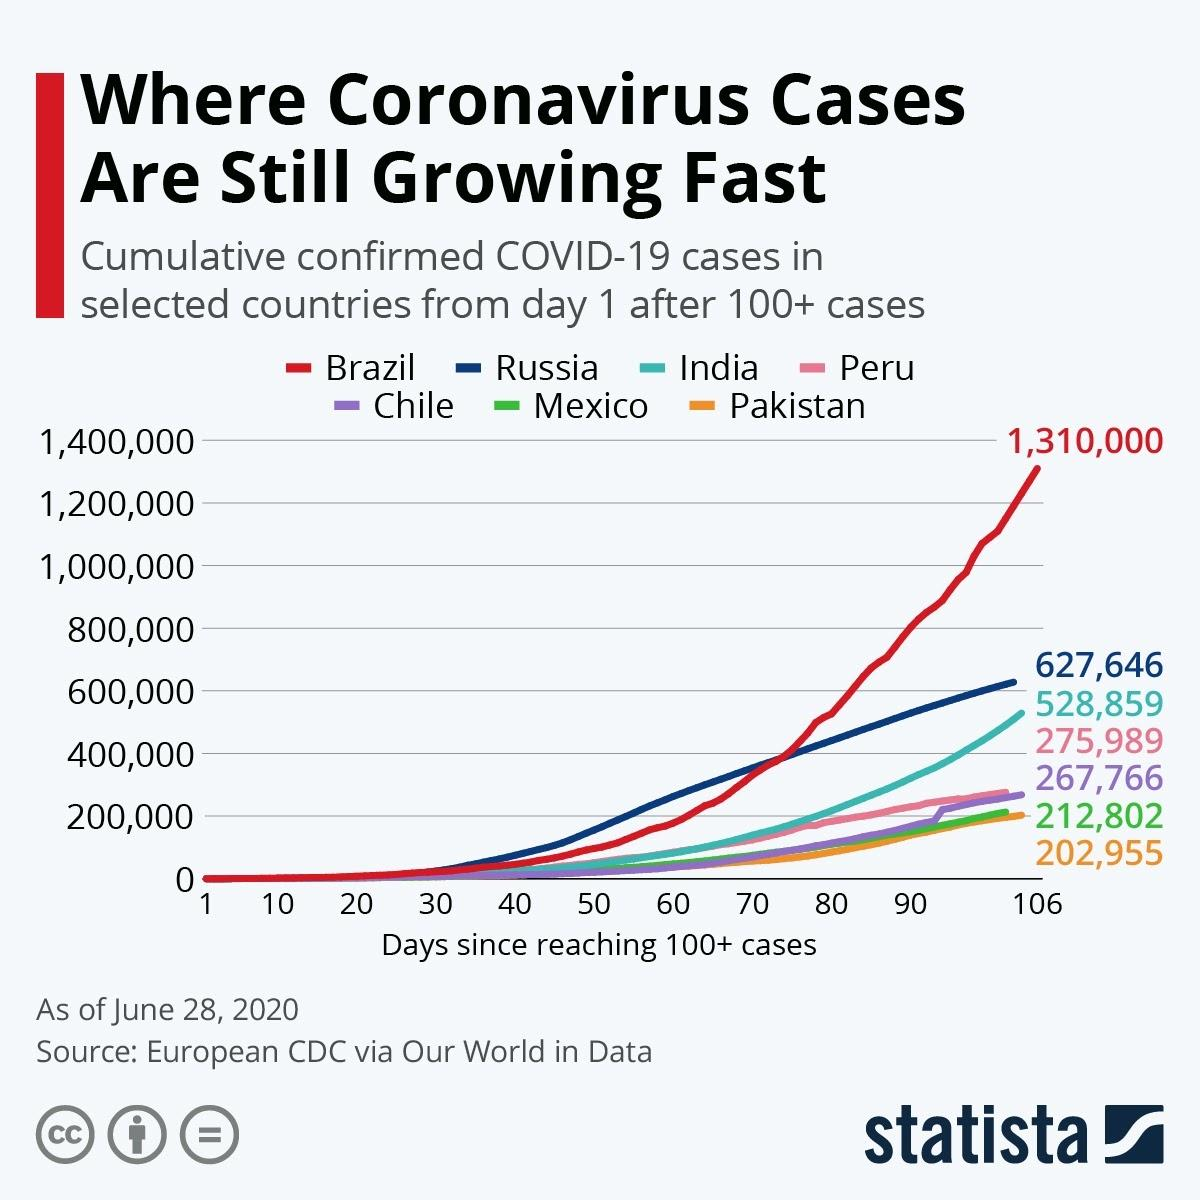Identify some key points in this picture. As of June 28, 2020, the cumulative number of confirmed COVID-19 cases in Peru was 275,989. As of June 28, 2020, the cumulative number of confirmed COVID-19 cases in India was 528,859. The second country with the lowest number of confirmed COVID-19 cases among the selected countries is Mexico. As of June 28, 2020, the cumulative number of confirmed COVID-19 cases in Brazil was 1,310,000. As of June 28, 2020, the cumulative number of confirmed COVID-19 cases in Chile was 267,766. 